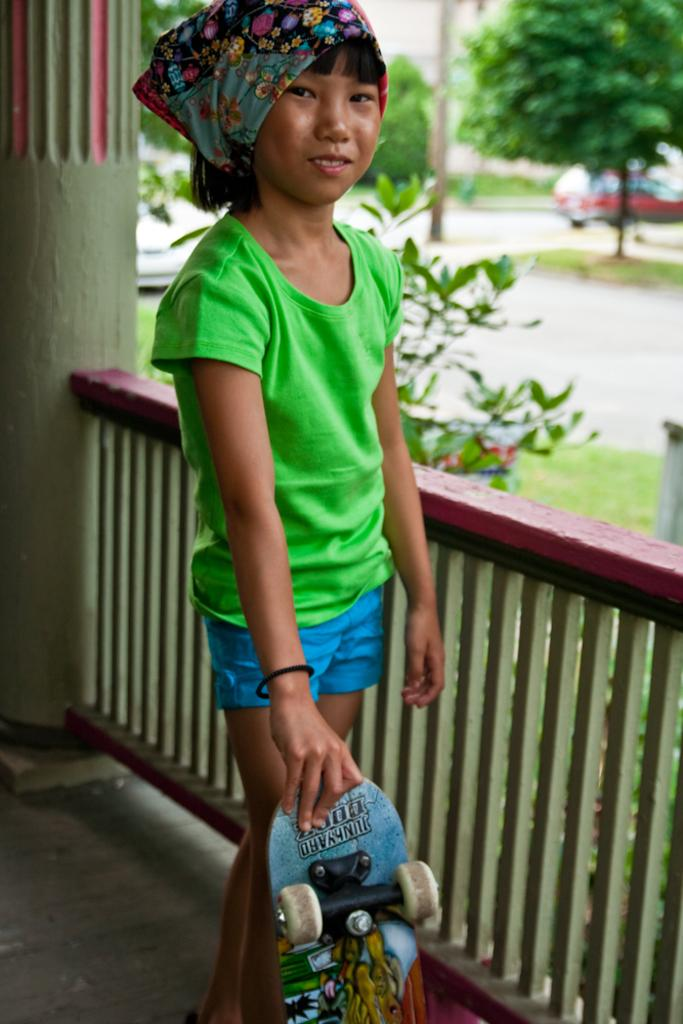Who is the main subject in the image? There is a girl in the image. What is the girl holding in the image? The girl is holding a skateboard. What can be seen in the background of the image? There is a fence, a pillar, a plant, a pole, a vehicle, and a tree visible in the image. What type of crime is being committed in the image? There is no crime being committed in the image; it features a girl holding a skateboard and various background elements. Can you tell me how many horses are present in the image? There are no horses present in the image. 